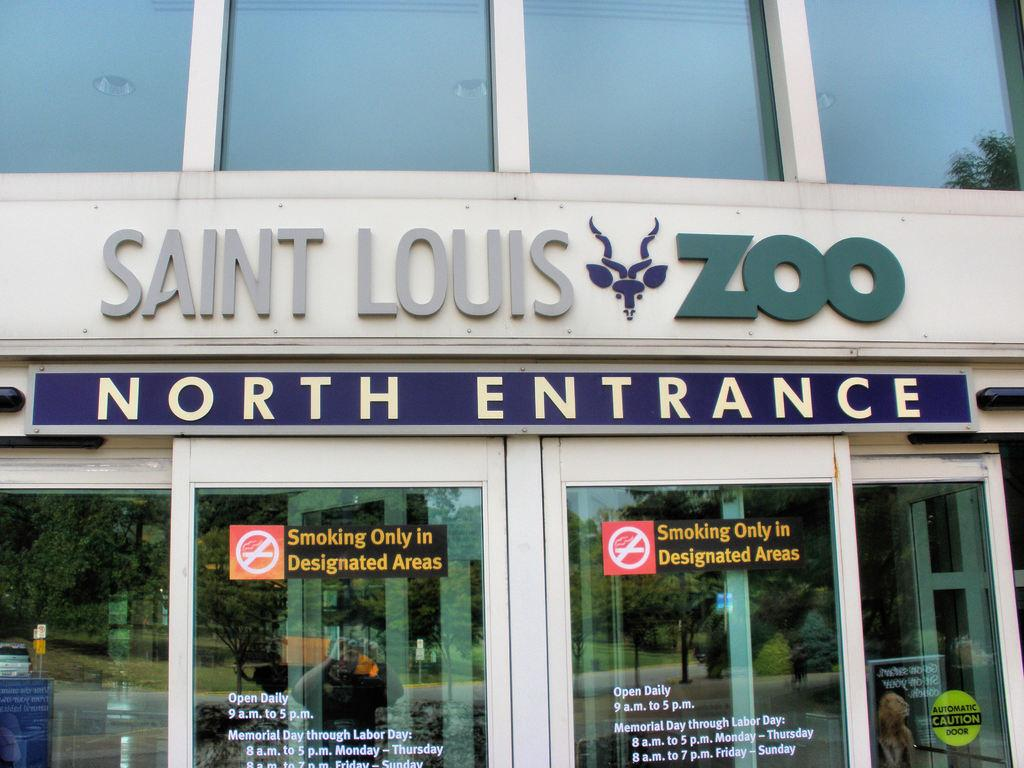What type of location is depicted in the image? The image appears to depict a zoo. What can be seen at the bottom of the image? There are glass walls at the bottom of the image. What is written or displayed in the middle of the image? The name of something (possibly an animal or exhibit) is present in the middle of the image. How many cats can be seen eating crackers in the image? There are no cats or crackers present in the image. What is the nationality of the animal depicted in the image? The image does not provide information about the nationality of any animals depicted. 